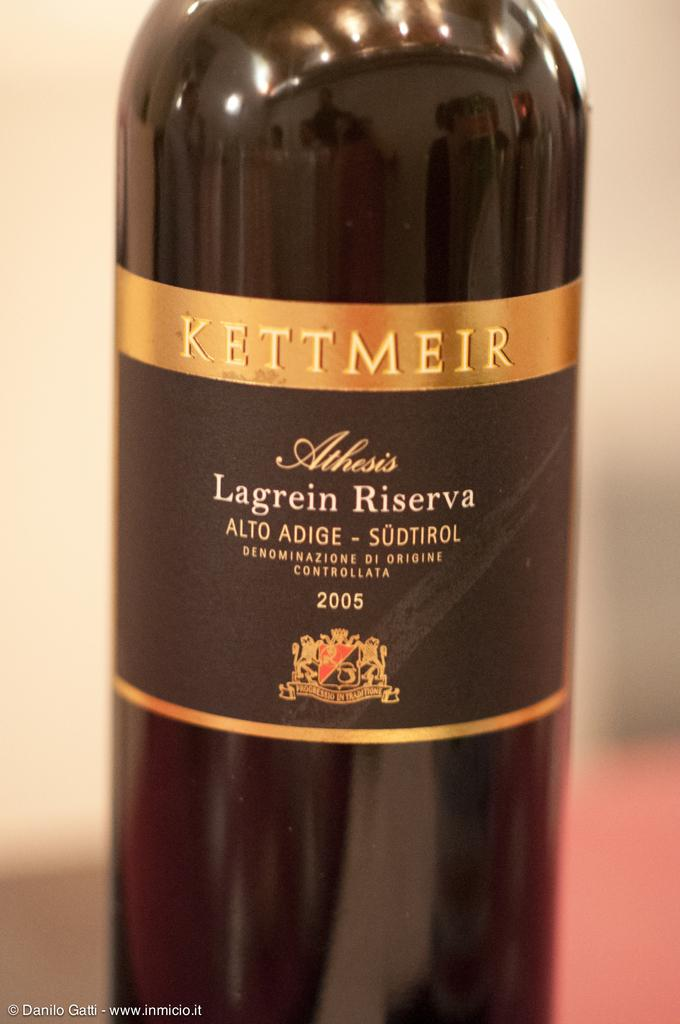Provide a one-sentence caption for the provided image. A bottle with a gold and black label reads "Kettmeir.". 